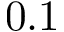<formula> <loc_0><loc_0><loc_500><loc_500>0 . 1</formula> 